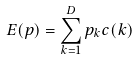Convert formula to latex. <formula><loc_0><loc_0><loc_500><loc_500>E ( p ) = \sum _ { k = 1 } ^ { D } p _ { k } c ( k )</formula> 